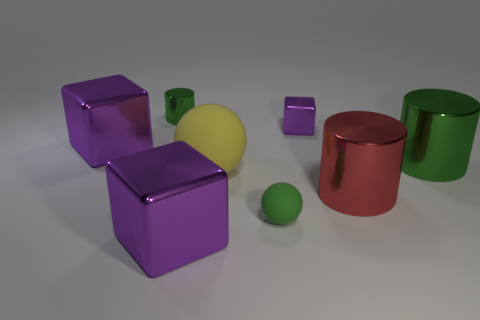Subtract all red cubes. Subtract all blue balls. How many cubes are left? 3 Add 2 large red metallic things. How many objects exist? 10 Subtract all spheres. How many objects are left? 6 Subtract all large red rubber cubes. Subtract all spheres. How many objects are left? 6 Add 5 big rubber spheres. How many big rubber spheres are left? 6 Add 6 red rubber blocks. How many red rubber blocks exist? 6 Subtract 0 gray spheres. How many objects are left? 8 